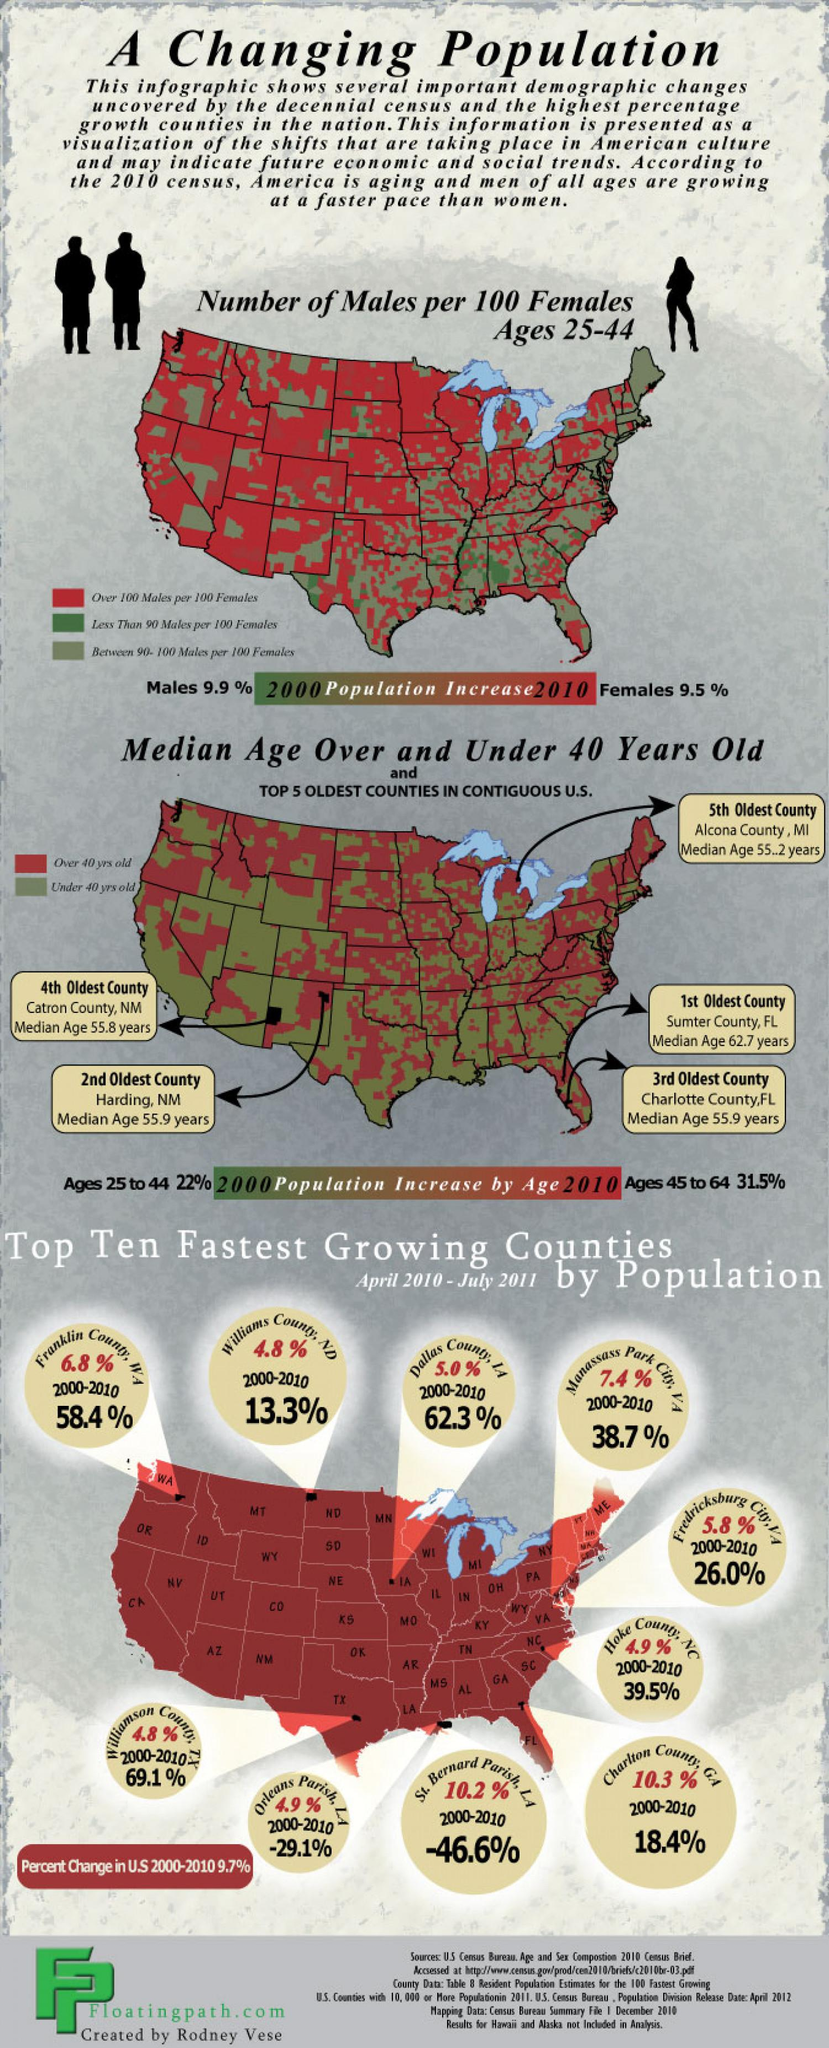Mention a couple of crucial points in this snapshot. During the period of 2000 to 2010, the population of Williams County in North Dakota increased by 13.3%. During the period of April 2010 to July 2011, the population growth rate in Dallas County was 5.0%. Williamson County in Texas had the fastest growing population during the period of April 2010 to July 2011 compared to the other counties in the state. During the period of April 2010 to July 2011, Hoke County in North Carolina had the fastest growing population among all the counties in the state. 